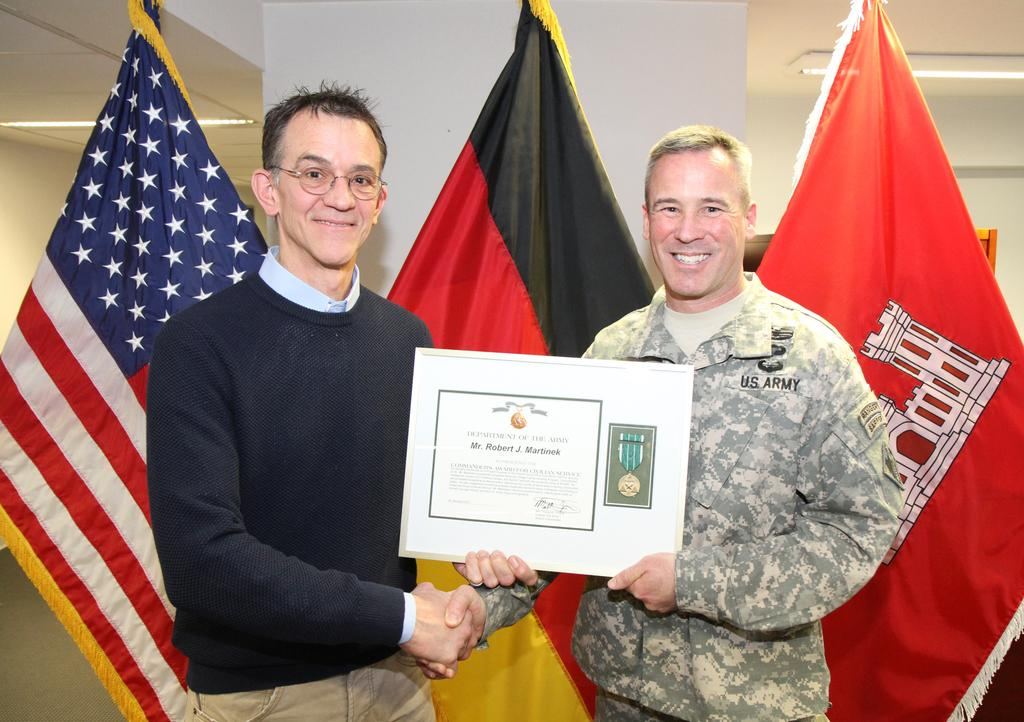How many people are in the image? There are two men in the image. What are the two men holding in the image? The two men are holding a certificate. What else can be seen in the image besides the two men? There are flags and a light in the image. What type of toys can be seen on the hill in the image? There is no hill or toys present in the image. 